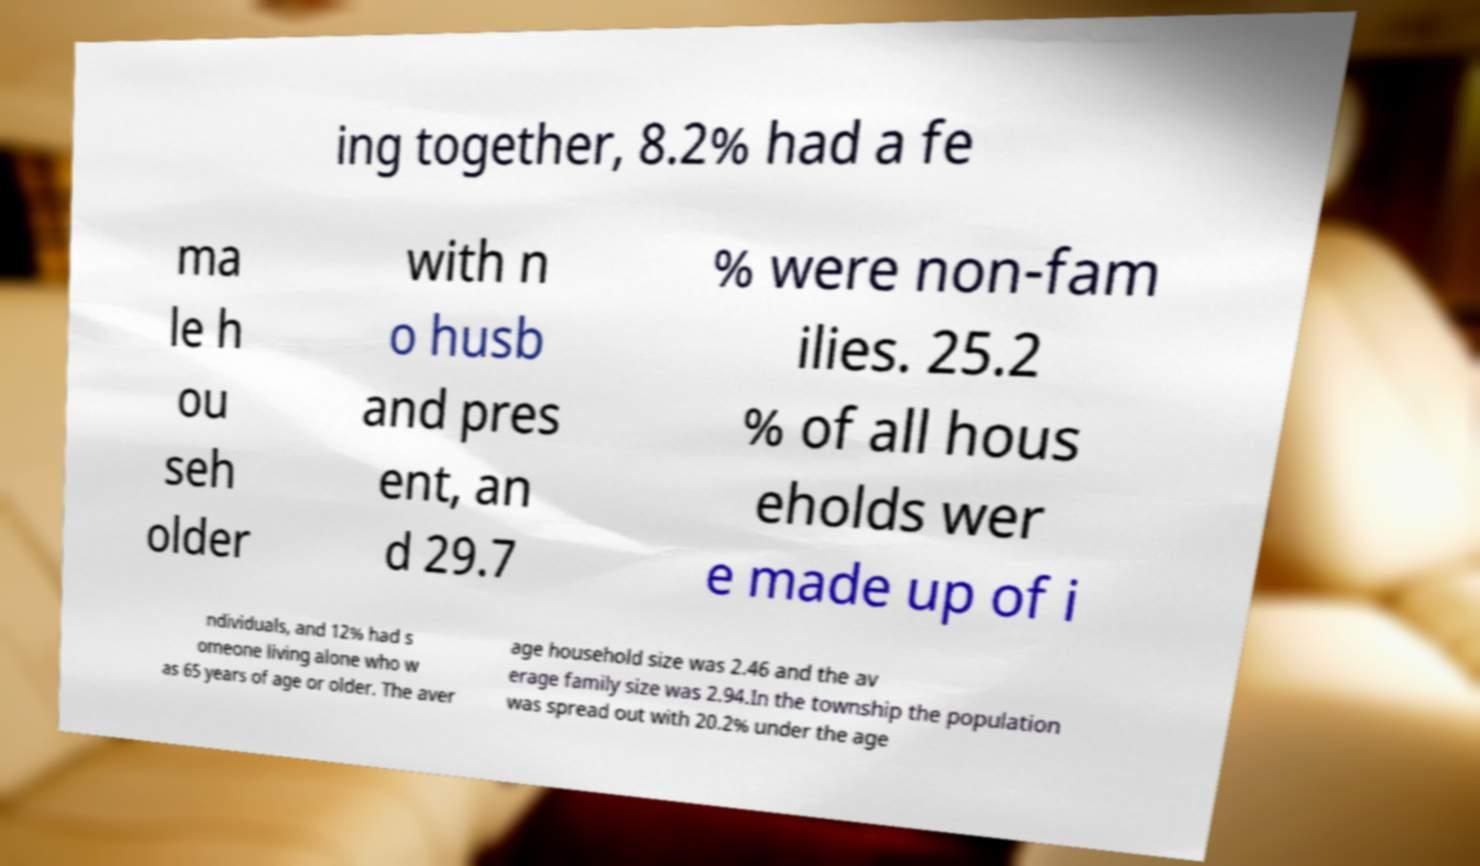There's text embedded in this image that I need extracted. Can you transcribe it verbatim? ing together, 8.2% had a fe ma le h ou seh older with n o husb and pres ent, an d 29.7 % were non-fam ilies. 25.2 % of all hous eholds wer e made up of i ndividuals, and 12% had s omeone living alone who w as 65 years of age or older. The aver age household size was 2.46 and the av erage family size was 2.94.In the township the population was spread out with 20.2% under the age 